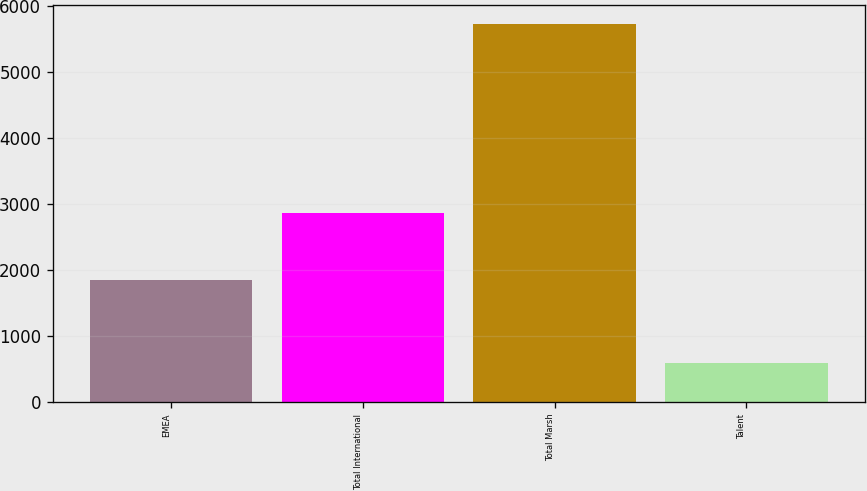<chart> <loc_0><loc_0><loc_500><loc_500><bar_chart><fcel>EMEA<fcel>Total International<fcel>Total Marsh<fcel>Talent<nl><fcel>1848<fcel>2864<fcel>5727<fcel>592<nl></chart> 